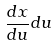<formula> <loc_0><loc_0><loc_500><loc_500>\frac { d x } { d u } d u</formula> 